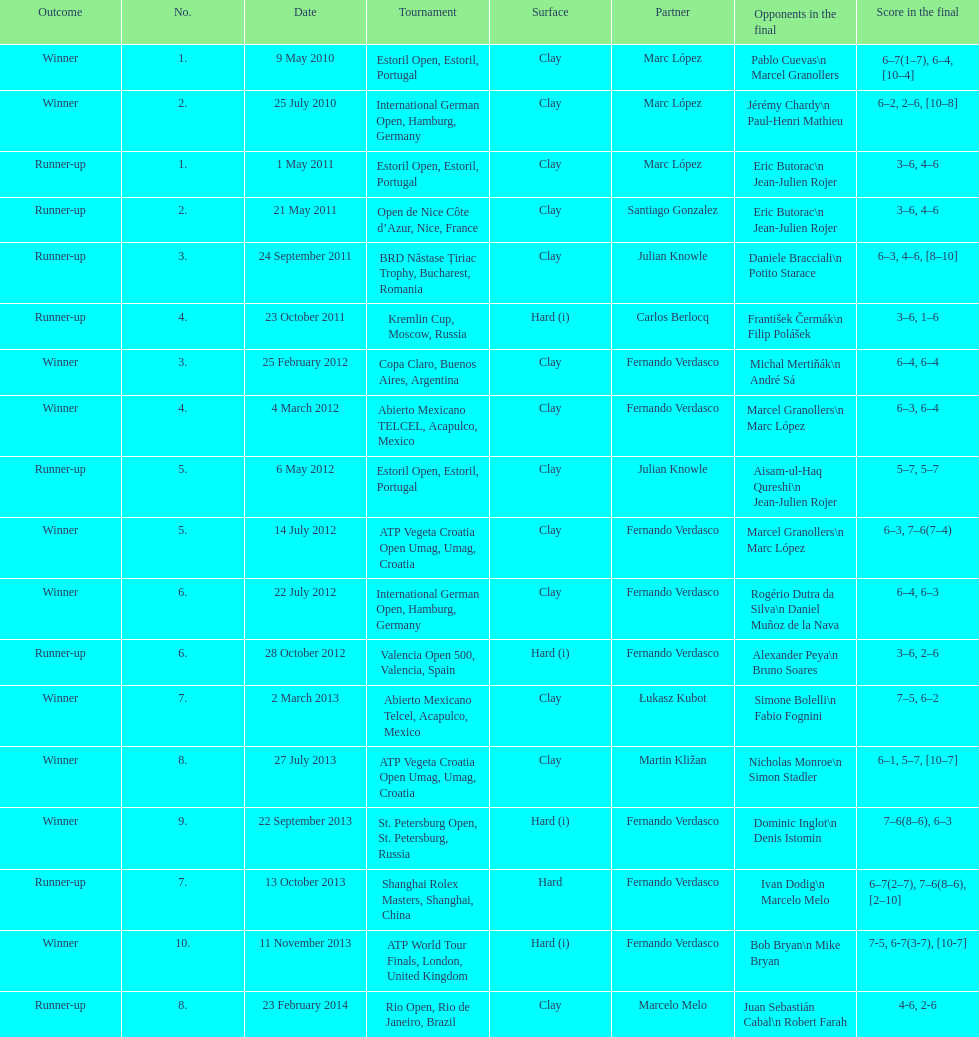How many listed partners are there from spain? 2. 